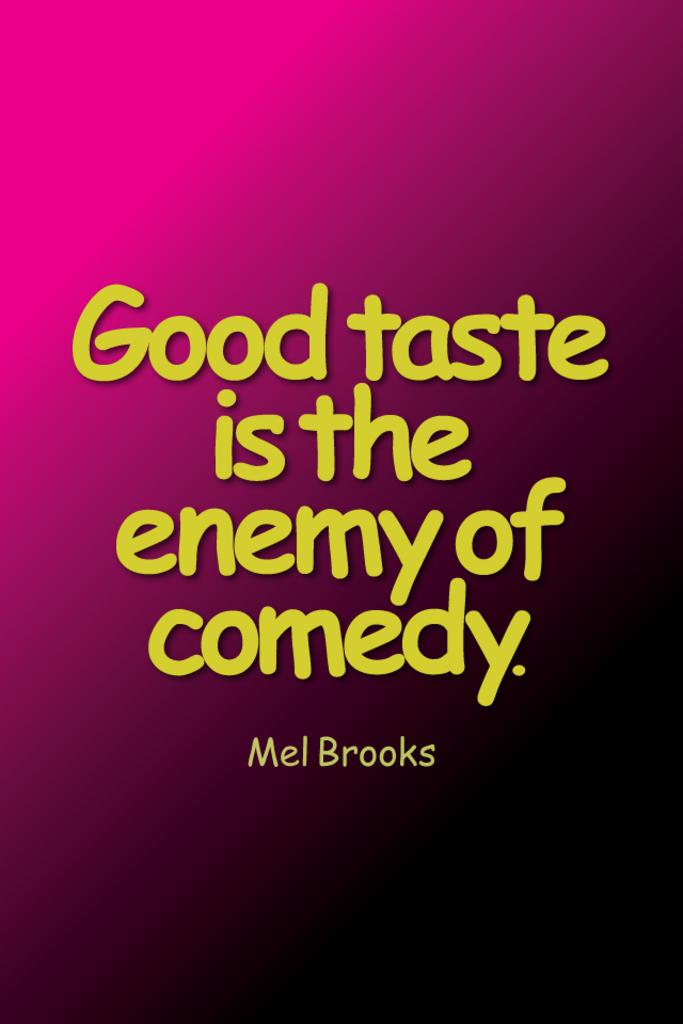<image>
Share a concise interpretation of the image provided. a pink and black page that says 'good taste is the enemy of comedy.' 